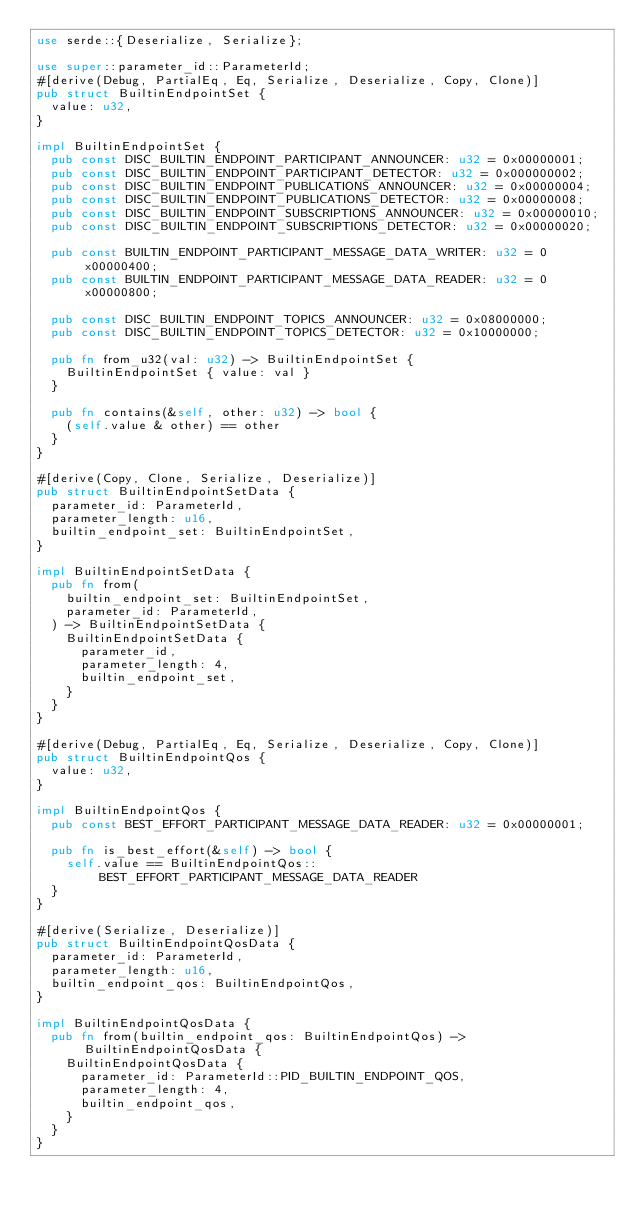Convert code to text. <code><loc_0><loc_0><loc_500><loc_500><_Rust_>use serde::{Deserialize, Serialize};

use super::parameter_id::ParameterId;
#[derive(Debug, PartialEq, Eq, Serialize, Deserialize, Copy, Clone)]
pub struct BuiltinEndpointSet {
  value: u32,
}

impl BuiltinEndpointSet {
  pub const DISC_BUILTIN_ENDPOINT_PARTICIPANT_ANNOUNCER: u32 = 0x00000001;
  pub const DISC_BUILTIN_ENDPOINT_PARTICIPANT_DETECTOR: u32 = 0x000000002;
  pub const DISC_BUILTIN_ENDPOINT_PUBLICATIONS_ANNOUNCER: u32 = 0x00000004;
  pub const DISC_BUILTIN_ENDPOINT_PUBLICATIONS_DETECTOR: u32 = 0x00000008;
  pub const DISC_BUILTIN_ENDPOINT_SUBSCRIPTIONS_ANNOUNCER: u32 = 0x00000010;
  pub const DISC_BUILTIN_ENDPOINT_SUBSCRIPTIONS_DETECTOR: u32 = 0x00000020;

  pub const BUILTIN_ENDPOINT_PARTICIPANT_MESSAGE_DATA_WRITER: u32 = 0x00000400;
  pub const BUILTIN_ENDPOINT_PARTICIPANT_MESSAGE_DATA_READER: u32 = 0x00000800;

  pub const DISC_BUILTIN_ENDPOINT_TOPICS_ANNOUNCER: u32 = 0x08000000;
  pub const DISC_BUILTIN_ENDPOINT_TOPICS_DETECTOR: u32 = 0x10000000;

  pub fn from_u32(val: u32) -> BuiltinEndpointSet {
    BuiltinEndpointSet { value: val }
  }

  pub fn contains(&self, other: u32) -> bool {
    (self.value & other) == other
  }
}

#[derive(Copy, Clone, Serialize, Deserialize)]
pub struct BuiltinEndpointSetData {
  parameter_id: ParameterId,
  parameter_length: u16,
  builtin_endpoint_set: BuiltinEndpointSet,
}

impl BuiltinEndpointSetData {
  pub fn from(
    builtin_endpoint_set: BuiltinEndpointSet,
    parameter_id: ParameterId,
  ) -> BuiltinEndpointSetData {
    BuiltinEndpointSetData {
      parameter_id,
      parameter_length: 4,
      builtin_endpoint_set,
    }
  }
}

#[derive(Debug, PartialEq, Eq, Serialize, Deserialize, Copy, Clone)]
pub struct BuiltinEndpointQos {
  value: u32,
}

impl BuiltinEndpointQos {
  pub const BEST_EFFORT_PARTICIPANT_MESSAGE_DATA_READER: u32 = 0x00000001;

  pub fn is_best_effort(&self) -> bool {
    self.value == BuiltinEndpointQos::BEST_EFFORT_PARTICIPANT_MESSAGE_DATA_READER
  }
}

#[derive(Serialize, Deserialize)]
pub struct BuiltinEndpointQosData {
  parameter_id: ParameterId,
  parameter_length: u16,
  builtin_endpoint_qos: BuiltinEndpointQos,
}

impl BuiltinEndpointQosData {
  pub fn from(builtin_endpoint_qos: BuiltinEndpointQos) -> BuiltinEndpointQosData {
    BuiltinEndpointQosData {
      parameter_id: ParameterId::PID_BUILTIN_ENDPOINT_QOS,
      parameter_length: 4,
      builtin_endpoint_qos,
    }
  }
}
</code> 